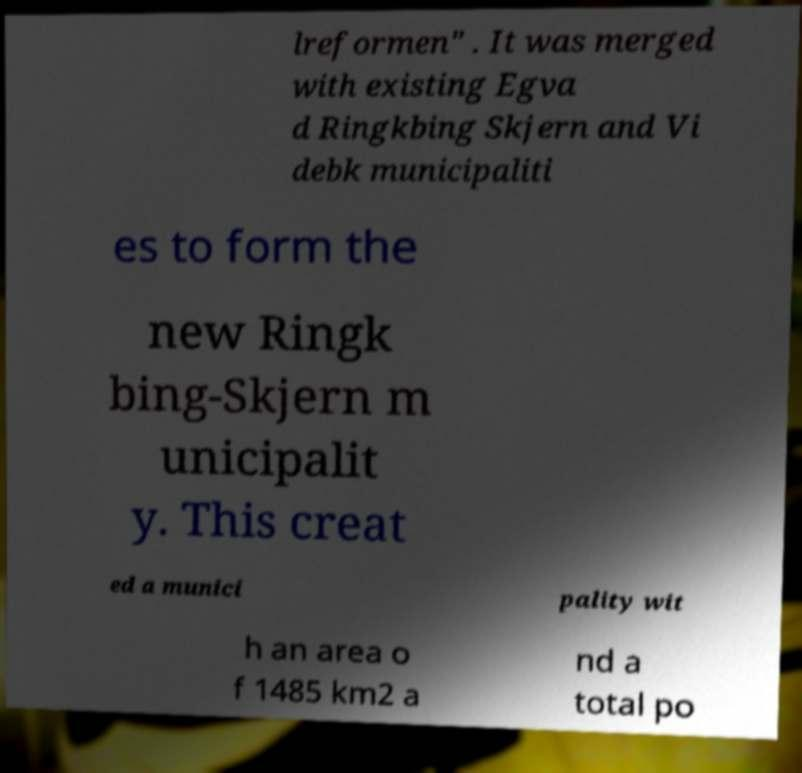Can you accurately transcribe the text from the provided image for me? lreformen" . It was merged with existing Egva d Ringkbing Skjern and Vi debk municipaliti es to form the new Ringk bing-Skjern m unicipalit y. This creat ed a munici pality wit h an area o f 1485 km2 a nd a total po 